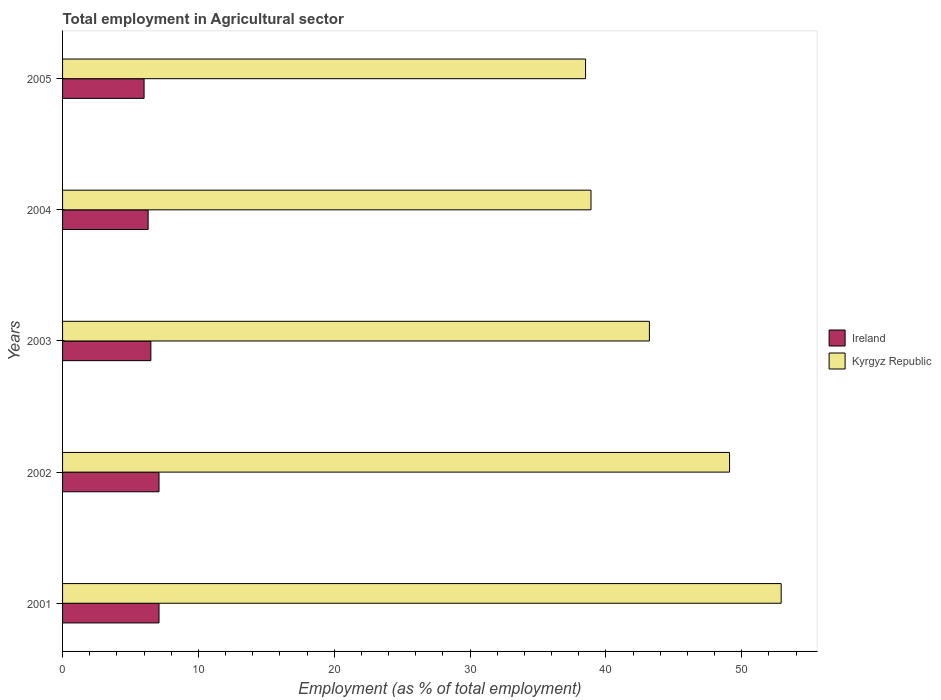How many different coloured bars are there?
Offer a very short reply. 2. How many groups of bars are there?
Offer a terse response. 5. How many bars are there on the 5th tick from the bottom?
Offer a very short reply. 2. What is the employment in agricultural sector in Ireland in 2004?
Keep it short and to the point. 6.3. Across all years, what is the maximum employment in agricultural sector in Kyrgyz Republic?
Keep it short and to the point. 52.9. Across all years, what is the minimum employment in agricultural sector in Kyrgyz Republic?
Give a very brief answer. 38.5. In which year was the employment in agricultural sector in Ireland maximum?
Make the answer very short. 2001. What is the total employment in agricultural sector in Kyrgyz Republic in the graph?
Your answer should be very brief. 222.6. What is the difference between the employment in agricultural sector in Kyrgyz Republic in 2003 and that in 2004?
Give a very brief answer. 4.3. What is the difference between the employment in agricultural sector in Kyrgyz Republic in 2004 and the employment in agricultural sector in Ireland in 2001?
Your response must be concise. 31.8. What is the average employment in agricultural sector in Kyrgyz Republic per year?
Ensure brevity in your answer.  44.52. In the year 2004, what is the difference between the employment in agricultural sector in Ireland and employment in agricultural sector in Kyrgyz Republic?
Offer a very short reply. -32.6. In how many years, is the employment in agricultural sector in Kyrgyz Republic greater than 40 %?
Ensure brevity in your answer.  3. What is the ratio of the employment in agricultural sector in Ireland in 2003 to that in 2005?
Offer a terse response. 1.08. Is the difference between the employment in agricultural sector in Ireland in 2001 and 2005 greater than the difference between the employment in agricultural sector in Kyrgyz Republic in 2001 and 2005?
Ensure brevity in your answer.  No. What is the difference between the highest and the second highest employment in agricultural sector in Kyrgyz Republic?
Keep it short and to the point. 3.8. What is the difference between the highest and the lowest employment in agricultural sector in Ireland?
Provide a short and direct response. 1.1. Is the sum of the employment in agricultural sector in Kyrgyz Republic in 2001 and 2003 greater than the maximum employment in agricultural sector in Ireland across all years?
Offer a terse response. Yes. What does the 1st bar from the top in 2005 represents?
Offer a terse response. Kyrgyz Republic. What does the 2nd bar from the bottom in 2003 represents?
Keep it short and to the point. Kyrgyz Republic. How many bars are there?
Your answer should be very brief. 10. What is the title of the graph?
Offer a very short reply. Total employment in Agricultural sector. Does "Netherlands" appear as one of the legend labels in the graph?
Ensure brevity in your answer.  No. What is the label or title of the X-axis?
Offer a very short reply. Employment (as % of total employment). What is the label or title of the Y-axis?
Make the answer very short. Years. What is the Employment (as % of total employment) of Ireland in 2001?
Keep it short and to the point. 7.1. What is the Employment (as % of total employment) in Kyrgyz Republic in 2001?
Ensure brevity in your answer.  52.9. What is the Employment (as % of total employment) in Ireland in 2002?
Keep it short and to the point. 7.1. What is the Employment (as % of total employment) in Kyrgyz Republic in 2002?
Offer a very short reply. 49.1. What is the Employment (as % of total employment) of Ireland in 2003?
Provide a short and direct response. 6.5. What is the Employment (as % of total employment) of Kyrgyz Republic in 2003?
Your answer should be very brief. 43.2. What is the Employment (as % of total employment) of Ireland in 2004?
Provide a succinct answer. 6.3. What is the Employment (as % of total employment) in Kyrgyz Republic in 2004?
Keep it short and to the point. 38.9. What is the Employment (as % of total employment) of Kyrgyz Republic in 2005?
Your answer should be very brief. 38.5. Across all years, what is the maximum Employment (as % of total employment) of Ireland?
Keep it short and to the point. 7.1. Across all years, what is the maximum Employment (as % of total employment) in Kyrgyz Republic?
Offer a very short reply. 52.9. Across all years, what is the minimum Employment (as % of total employment) in Ireland?
Give a very brief answer. 6. Across all years, what is the minimum Employment (as % of total employment) of Kyrgyz Republic?
Provide a short and direct response. 38.5. What is the total Employment (as % of total employment) of Kyrgyz Republic in the graph?
Keep it short and to the point. 222.6. What is the difference between the Employment (as % of total employment) of Ireland in 2001 and that in 2002?
Your answer should be compact. 0. What is the difference between the Employment (as % of total employment) of Kyrgyz Republic in 2001 and that in 2002?
Your answer should be very brief. 3.8. What is the difference between the Employment (as % of total employment) of Kyrgyz Republic in 2001 and that in 2004?
Offer a terse response. 14. What is the difference between the Employment (as % of total employment) of Ireland in 2002 and that in 2003?
Provide a succinct answer. 0.6. What is the difference between the Employment (as % of total employment) of Kyrgyz Republic in 2002 and that in 2003?
Your answer should be compact. 5.9. What is the difference between the Employment (as % of total employment) of Ireland in 2002 and that in 2004?
Make the answer very short. 0.8. What is the difference between the Employment (as % of total employment) in Kyrgyz Republic in 2002 and that in 2004?
Make the answer very short. 10.2. What is the difference between the Employment (as % of total employment) of Ireland in 2002 and that in 2005?
Provide a succinct answer. 1.1. What is the difference between the Employment (as % of total employment) in Kyrgyz Republic in 2002 and that in 2005?
Your answer should be compact. 10.6. What is the difference between the Employment (as % of total employment) in Kyrgyz Republic in 2003 and that in 2004?
Ensure brevity in your answer.  4.3. What is the difference between the Employment (as % of total employment) of Ireland in 2003 and that in 2005?
Provide a short and direct response. 0.5. What is the difference between the Employment (as % of total employment) in Kyrgyz Republic in 2003 and that in 2005?
Your answer should be very brief. 4.7. What is the difference between the Employment (as % of total employment) in Ireland in 2004 and that in 2005?
Make the answer very short. 0.3. What is the difference between the Employment (as % of total employment) of Ireland in 2001 and the Employment (as % of total employment) of Kyrgyz Republic in 2002?
Keep it short and to the point. -42. What is the difference between the Employment (as % of total employment) in Ireland in 2001 and the Employment (as % of total employment) in Kyrgyz Republic in 2003?
Make the answer very short. -36.1. What is the difference between the Employment (as % of total employment) of Ireland in 2001 and the Employment (as % of total employment) of Kyrgyz Republic in 2004?
Your answer should be very brief. -31.8. What is the difference between the Employment (as % of total employment) in Ireland in 2001 and the Employment (as % of total employment) in Kyrgyz Republic in 2005?
Offer a terse response. -31.4. What is the difference between the Employment (as % of total employment) of Ireland in 2002 and the Employment (as % of total employment) of Kyrgyz Republic in 2003?
Offer a terse response. -36.1. What is the difference between the Employment (as % of total employment) in Ireland in 2002 and the Employment (as % of total employment) in Kyrgyz Republic in 2004?
Give a very brief answer. -31.8. What is the difference between the Employment (as % of total employment) in Ireland in 2002 and the Employment (as % of total employment) in Kyrgyz Republic in 2005?
Make the answer very short. -31.4. What is the difference between the Employment (as % of total employment) in Ireland in 2003 and the Employment (as % of total employment) in Kyrgyz Republic in 2004?
Your answer should be very brief. -32.4. What is the difference between the Employment (as % of total employment) in Ireland in 2003 and the Employment (as % of total employment) in Kyrgyz Republic in 2005?
Ensure brevity in your answer.  -32. What is the difference between the Employment (as % of total employment) of Ireland in 2004 and the Employment (as % of total employment) of Kyrgyz Republic in 2005?
Keep it short and to the point. -32.2. What is the average Employment (as % of total employment) of Ireland per year?
Your answer should be compact. 6.6. What is the average Employment (as % of total employment) of Kyrgyz Republic per year?
Give a very brief answer. 44.52. In the year 2001, what is the difference between the Employment (as % of total employment) of Ireland and Employment (as % of total employment) of Kyrgyz Republic?
Your answer should be very brief. -45.8. In the year 2002, what is the difference between the Employment (as % of total employment) in Ireland and Employment (as % of total employment) in Kyrgyz Republic?
Make the answer very short. -42. In the year 2003, what is the difference between the Employment (as % of total employment) of Ireland and Employment (as % of total employment) of Kyrgyz Republic?
Keep it short and to the point. -36.7. In the year 2004, what is the difference between the Employment (as % of total employment) in Ireland and Employment (as % of total employment) in Kyrgyz Republic?
Offer a terse response. -32.6. In the year 2005, what is the difference between the Employment (as % of total employment) of Ireland and Employment (as % of total employment) of Kyrgyz Republic?
Ensure brevity in your answer.  -32.5. What is the ratio of the Employment (as % of total employment) in Kyrgyz Republic in 2001 to that in 2002?
Your answer should be compact. 1.08. What is the ratio of the Employment (as % of total employment) in Ireland in 2001 to that in 2003?
Provide a succinct answer. 1.09. What is the ratio of the Employment (as % of total employment) of Kyrgyz Republic in 2001 to that in 2003?
Provide a succinct answer. 1.22. What is the ratio of the Employment (as % of total employment) of Ireland in 2001 to that in 2004?
Offer a terse response. 1.13. What is the ratio of the Employment (as % of total employment) of Kyrgyz Republic in 2001 to that in 2004?
Provide a short and direct response. 1.36. What is the ratio of the Employment (as % of total employment) of Ireland in 2001 to that in 2005?
Keep it short and to the point. 1.18. What is the ratio of the Employment (as % of total employment) in Kyrgyz Republic in 2001 to that in 2005?
Your answer should be very brief. 1.37. What is the ratio of the Employment (as % of total employment) of Ireland in 2002 to that in 2003?
Offer a terse response. 1.09. What is the ratio of the Employment (as % of total employment) in Kyrgyz Republic in 2002 to that in 2003?
Your response must be concise. 1.14. What is the ratio of the Employment (as % of total employment) of Ireland in 2002 to that in 2004?
Provide a succinct answer. 1.13. What is the ratio of the Employment (as % of total employment) of Kyrgyz Republic in 2002 to that in 2004?
Keep it short and to the point. 1.26. What is the ratio of the Employment (as % of total employment) of Ireland in 2002 to that in 2005?
Your response must be concise. 1.18. What is the ratio of the Employment (as % of total employment) in Kyrgyz Republic in 2002 to that in 2005?
Ensure brevity in your answer.  1.28. What is the ratio of the Employment (as % of total employment) of Ireland in 2003 to that in 2004?
Offer a very short reply. 1.03. What is the ratio of the Employment (as % of total employment) in Kyrgyz Republic in 2003 to that in 2004?
Ensure brevity in your answer.  1.11. What is the ratio of the Employment (as % of total employment) of Ireland in 2003 to that in 2005?
Keep it short and to the point. 1.08. What is the ratio of the Employment (as % of total employment) in Kyrgyz Republic in 2003 to that in 2005?
Your response must be concise. 1.12. What is the ratio of the Employment (as % of total employment) of Kyrgyz Republic in 2004 to that in 2005?
Keep it short and to the point. 1.01. What is the difference between the highest and the second highest Employment (as % of total employment) of Ireland?
Your response must be concise. 0. What is the difference between the highest and the lowest Employment (as % of total employment) in Kyrgyz Republic?
Keep it short and to the point. 14.4. 